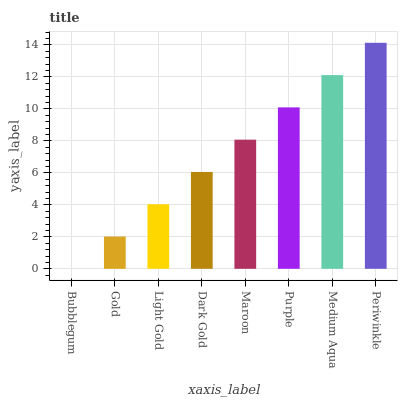Is Bubblegum the minimum?
Answer yes or no. Yes. Is Periwinkle the maximum?
Answer yes or no. Yes. Is Gold the minimum?
Answer yes or no. No. Is Gold the maximum?
Answer yes or no. No. Is Gold greater than Bubblegum?
Answer yes or no. Yes. Is Bubblegum less than Gold?
Answer yes or no. Yes. Is Bubblegum greater than Gold?
Answer yes or no. No. Is Gold less than Bubblegum?
Answer yes or no. No. Is Maroon the high median?
Answer yes or no. Yes. Is Dark Gold the low median?
Answer yes or no. Yes. Is Periwinkle the high median?
Answer yes or no. No. Is Gold the low median?
Answer yes or no. No. 